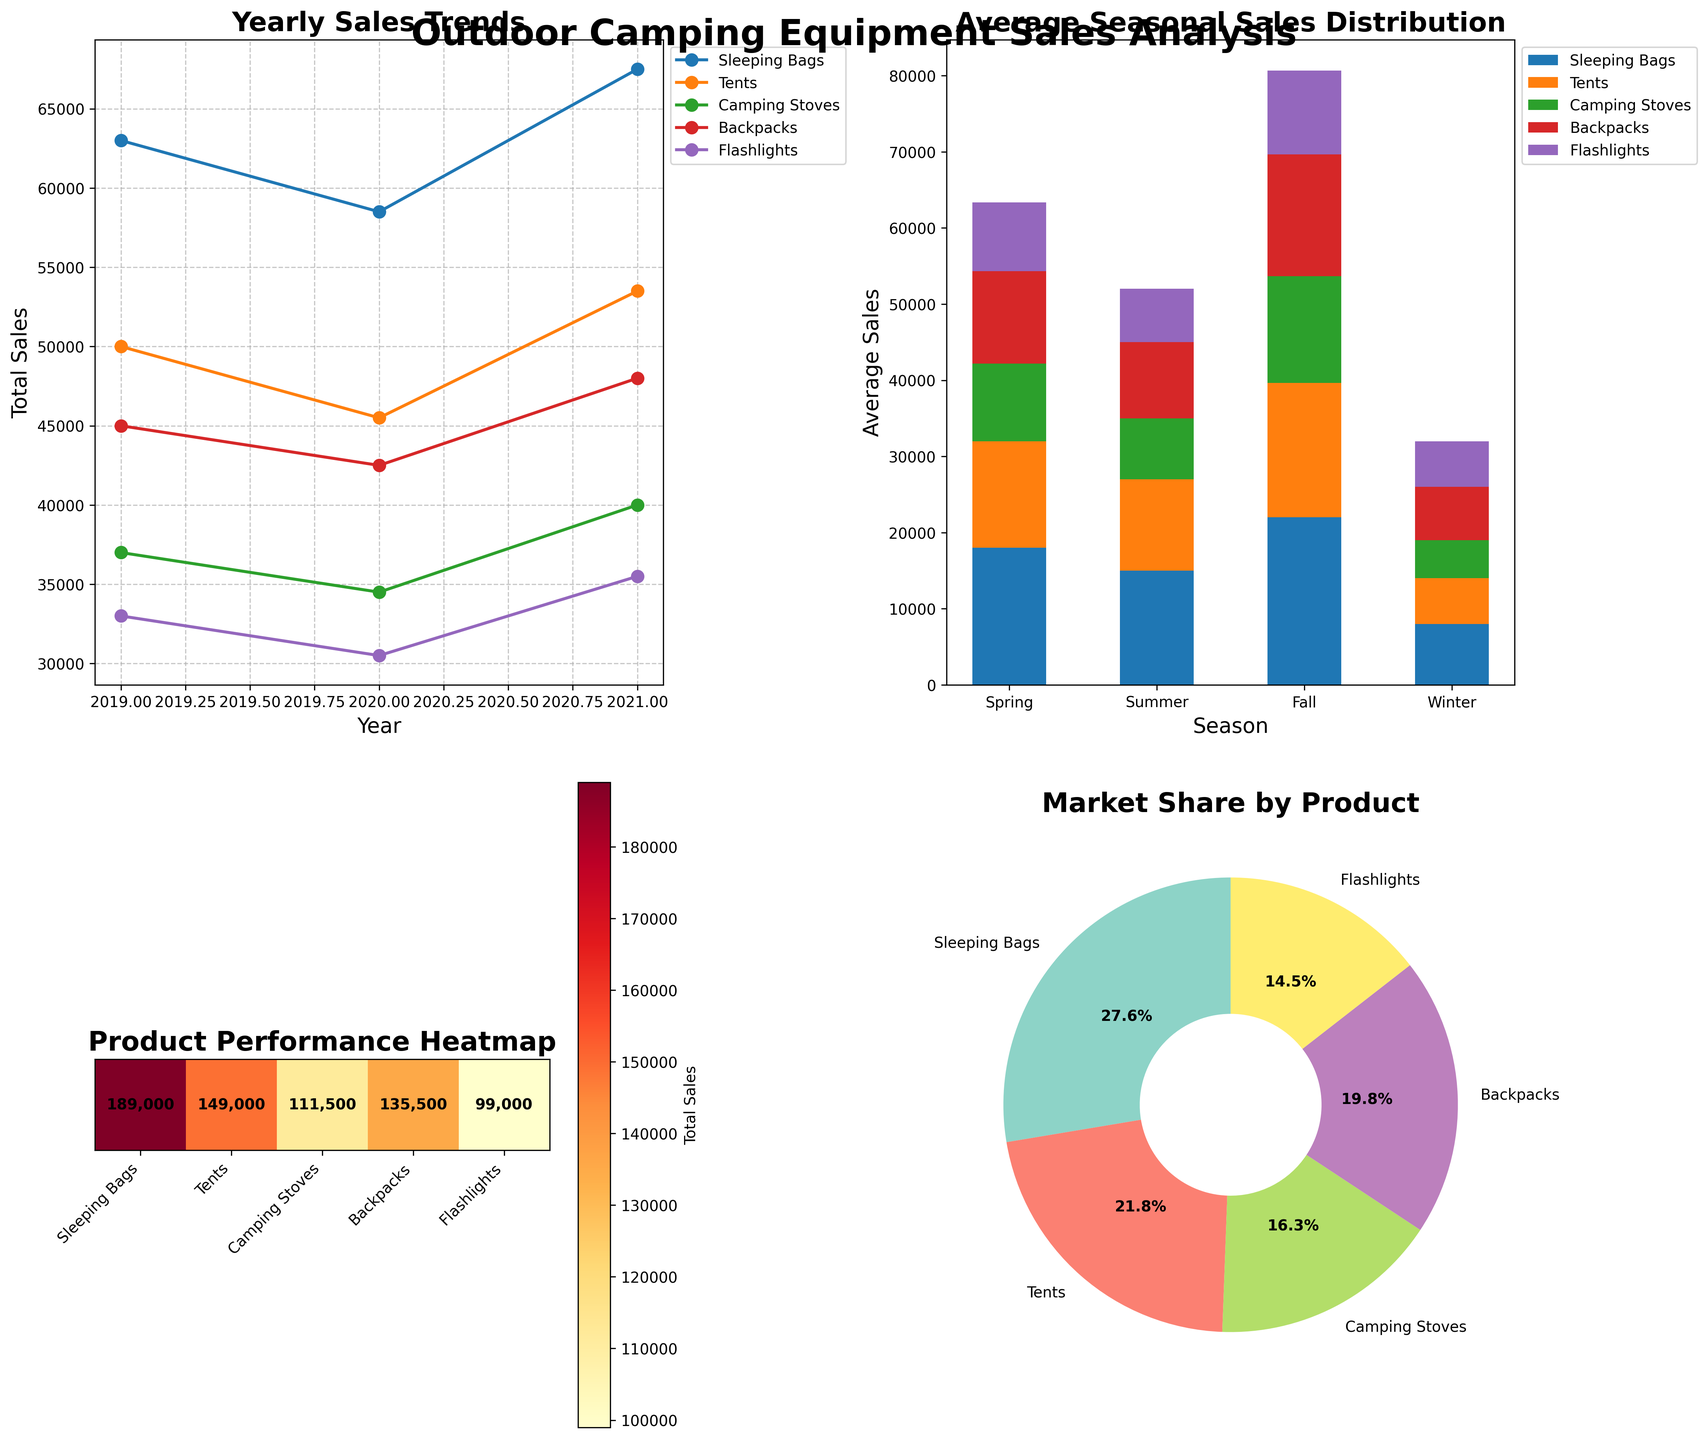Which year had the highest total sales for outdoor camping equipment? In the line plot (Subplot 1), look at the highest values for each product and sum them for comparison across years. In 2021, the plot lines for all products reach higher peaks compared to other years.
Answer: 2021 Which product had the lowest average seasonal sales? In the stacked bar chart (Subplot 2), look for the product which consistently has the smallest segments across all seasons. Camping Stoves show the lowest bars in all seasons.
Answer: Camping Stoves How does the total sales of Tents in 2019 compare to the total sales of Backpacks in the same year? Using the heat map (Subplot 3), sum the sales for Tents and Backpacks for 2019. Tents in 2019 sold 12000 + 18000 + 14000 + 6000 = 50000 units, whereas Backpacks sold 10000 + 16000 + 12000 + 7000 = 45000 units.
Answer: Tents had higher sales Which season shows the highest overall sales on average for all the products? In the stacked bar chart (Subplot 2), observe which season's bars collectively reach the highest. Summer shows the highest combined bar heights for average seasonal sales.
Answer: Summer What was the percentage market share of Sleeping Bags? In the pie chart (Subplot 4), observe the wedge labeled "Sleeping Bags" to see its percentage of the total sales. It is shown as 25.6%.
Answer: 25.6% Did Flashlights have an increasing or decreasing trend in sales from 2019 to 2021? In the line plot (Subplot 1), follow the line corresponding to Flashlights from 2019 through 2021 to see the overall trend. The line for Flashlights generally increases across years.
Answer: Increasing How does the total sales of Camping Stoves in 2020 compare to Flashlights in 2020? Using the heat map (Subplot 3), sum the sales for Camping Stoves and Flashlights in 2020. Camping Stoves in 2020 sold 7500 + 13000 + 9500 + 4500 = 34500 units, whereas Flashlights sold 6500 + 10000 + 8500 + 5500 = 30500 units.
Answer: Camping Stoves had higher sales Which season experienced the least variation in sales among the products? In the stacked bar chart (Subplot 2), check which season has the most balanced height distribution among different products. Winter has more evenly distributed sales among the different products.
Answer: Winter 